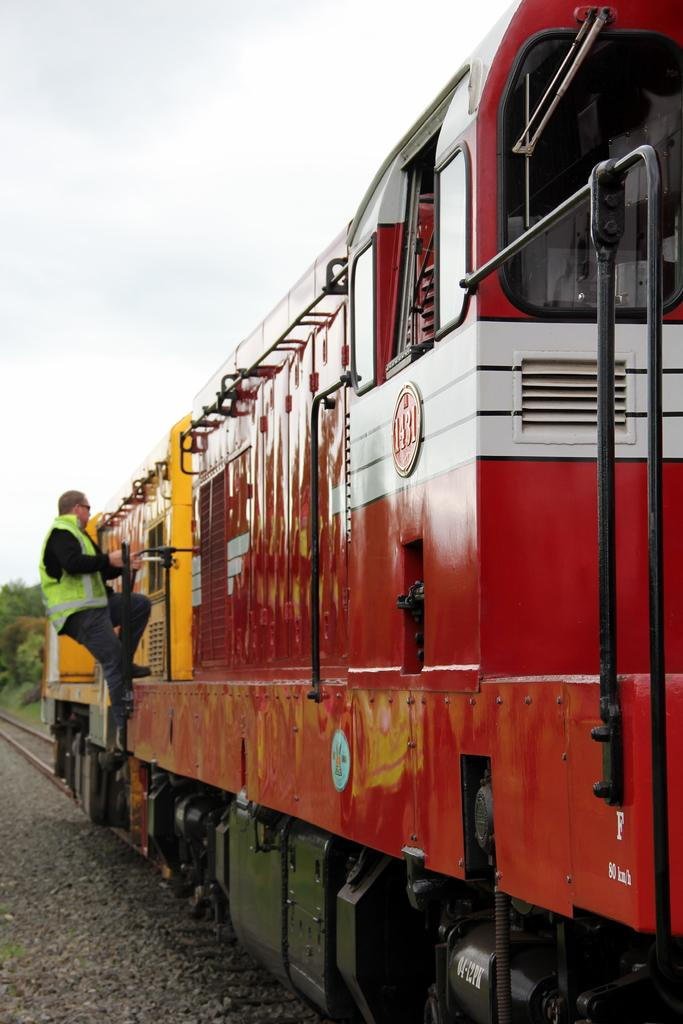What is the main subject of the image? The main subject of the image is a train. Where is the train located in the image? The train is on a track. What is the person on the train doing? The person on the train is holding rods. What type of natural elements can be seen in the image? There are stones and trees visible in the image. What is visible in the background of the image? The sky is visible in the image. What type of soup is being served on the train in the image? There is no soup present in the image; it features a train on a track with a person holding rods. Can you see a balloon in the image? There is no balloon present in the image. 